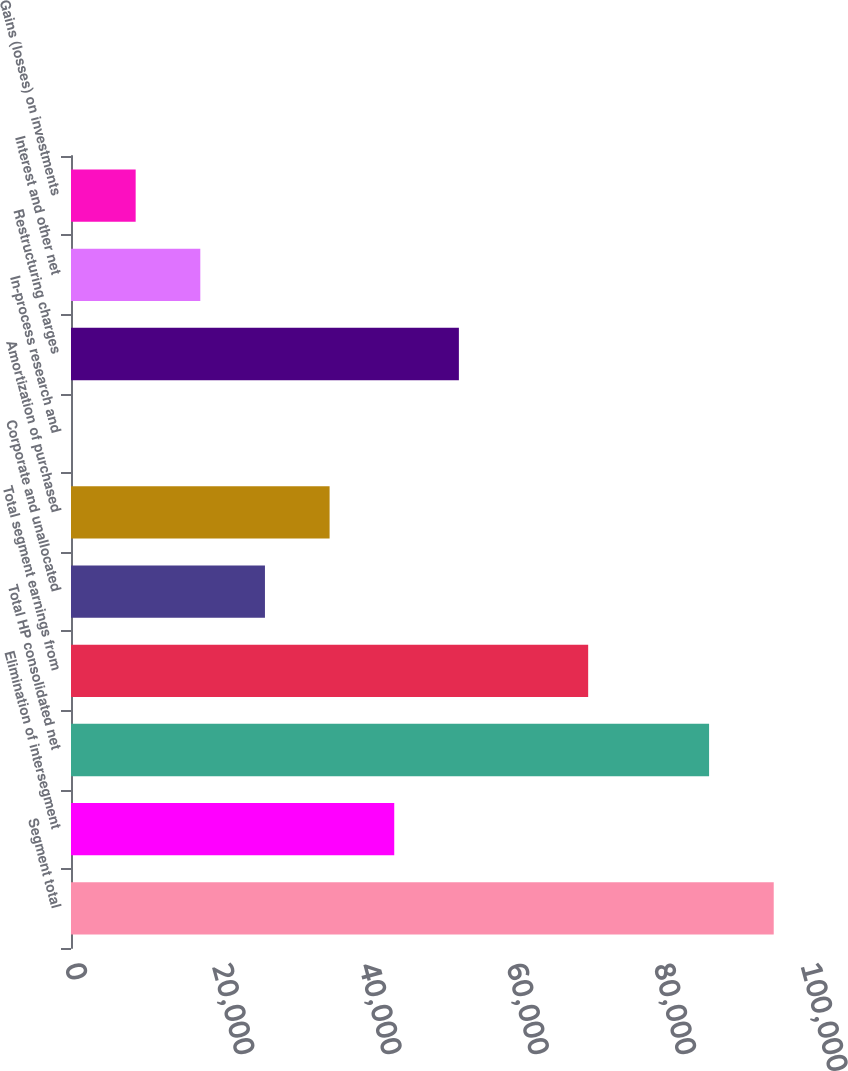Convert chart to OTSL. <chart><loc_0><loc_0><loc_500><loc_500><bar_chart><fcel>Segment total<fcel>Elimination of intersegment<fcel>Total HP consolidated net<fcel>Total segment earnings from<fcel>Corporate and unallocated<fcel>Amortization of purchased<fcel>In-process research and<fcel>Restructuring charges<fcel>Interest and other net<fcel>Gains (losses) on investments<nl><fcel>95479.3<fcel>43918.5<fcel>86696<fcel>70268.4<fcel>26351.9<fcel>35135.2<fcel>2<fcel>52701.8<fcel>17568.6<fcel>8785.3<nl></chart> 